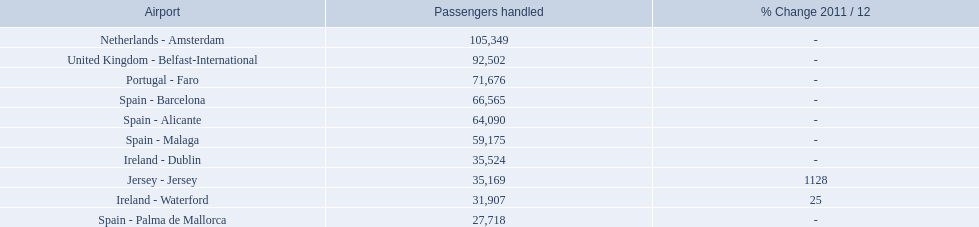What are the airports? Netherlands - Amsterdam, United Kingdom - Belfast-International, Portugal - Faro, Spain - Barcelona, Spain - Alicante, Spain - Malaga, Ireland - Dublin, Jersey - Jersey, Ireland - Waterford, Spain - Palma de Mallorca. Of these which has the least amount of passengers? Spain - Palma de Mallorca. Which airports had passengers going through london southend airport? Netherlands - Amsterdam, United Kingdom - Belfast-International, Portugal - Faro, Spain - Barcelona, Spain - Alicante, Spain - Malaga, Ireland - Dublin, Jersey - Jersey, Ireland - Waterford, Spain - Palma de Mallorca. Of those airports, which airport had the least amount of passengers going through london southend airport? Spain - Palma de Mallorca. What are all the airports in the top 10 busiest routes to and from london southend airport? Netherlands - Amsterdam, United Kingdom - Belfast-International, Portugal - Faro, Spain - Barcelona, Spain - Alicante, Spain - Malaga, Ireland - Dublin, Jersey - Jersey, Ireland - Waterford, Spain - Palma de Mallorca. Which airports are in portugal? Portugal - Faro. 